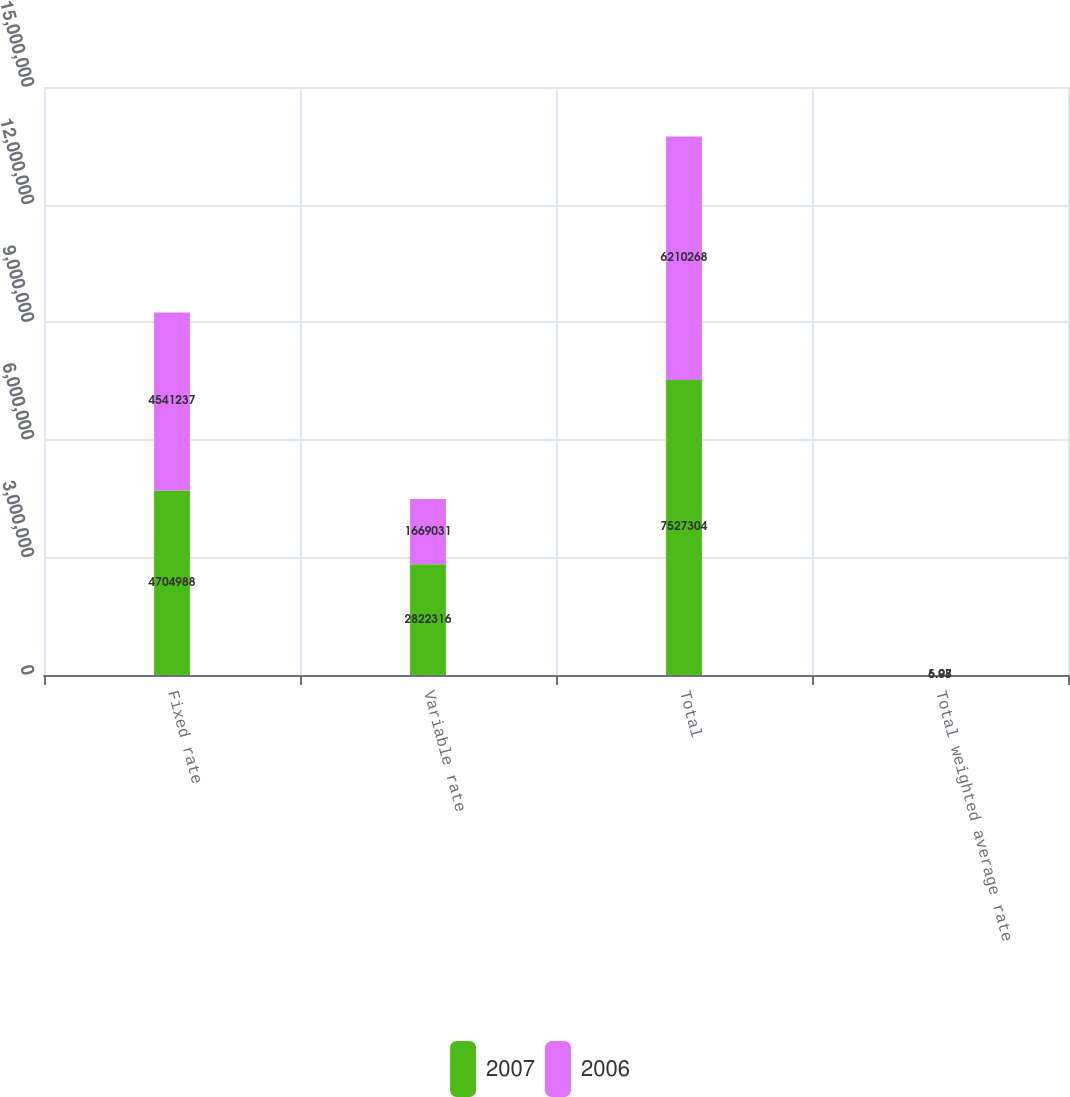Convert chart to OTSL. <chart><loc_0><loc_0><loc_500><loc_500><stacked_bar_chart><ecel><fcel>Fixed rate<fcel>Variable rate<fcel>Total<fcel>Total weighted average rate<nl><fcel>2007<fcel>4.70499e+06<fcel>2.82232e+06<fcel>7.5273e+06<fcel>6.08<nl><fcel>2006<fcel>4.54124e+06<fcel>1.66903e+06<fcel>6.21027e+06<fcel>5.97<nl></chart> 